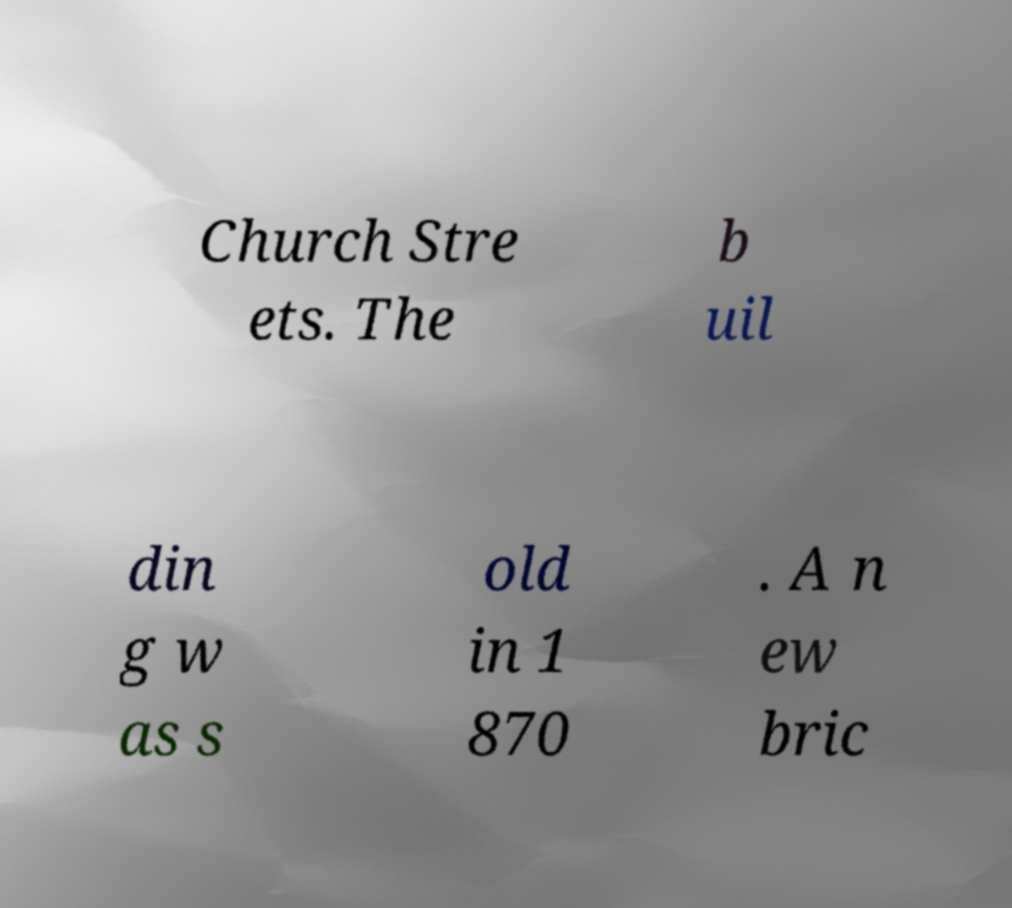Can you read and provide the text displayed in the image?This photo seems to have some interesting text. Can you extract and type it out for me? Church Stre ets. The b uil din g w as s old in 1 870 . A n ew bric 